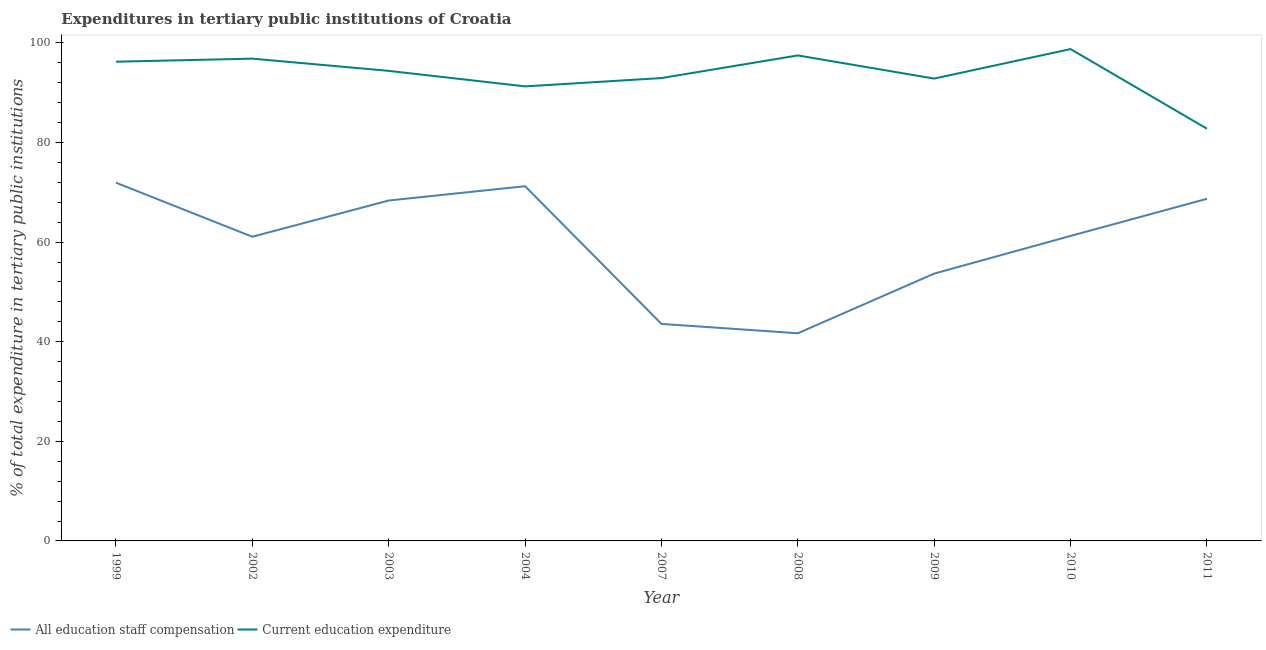How many different coloured lines are there?
Offer a terse response. 2. Is the number of lines equal to the number of legend labels?
Keep it short and to the point. Yes. What is the expenditure in education in 2004?
Provide a short and direct response. 91.28. Across all years, what is the maximum expenditure in staff compensation?
Give a very brief answer. 71.95. Across all years, what is the minimum expenditure in staff compensation?
Give a very brief answer. 41.7. In which year was the expenditure in education maximum?
Keep it short and to the point. 2010. What is the total expenditure in education in the graph?
Offer a terse response. 843.66. What is the difference between the expenditure in staff compensation in 2002 and that in 2010?
Make the answer very short. -0.17. What is the difference between the expenditure in education in 2003 and the expenditure in staff compensation in 2002?
Keep it short and to the point. 33.32. What is the average expenditure in education per year?
Keep it short and to the point. 93.74. In the year 2004, what is the difference between the expenditure in education and expenditure in staff compensation?
Give a very brief answer. 20.05. In how many years, is the expenditure in staff compensation greater than 36 %?
Provide a short and direct response. 9. What is the ratio of the expenditure in education in 2007 to that in 2008?
Your response must be concise. 0.95. Is the expenditure in education in 2008 less than that in 2011?
Ensure brevity in your answer.  No. Is the difference between the expenditure in education in 2007 and 2010 greater than the difference between the expenditure in staff compensation in 2007 and 2010?
Keep it short and to the point. Yes. What is the difference between the highest and the second highest expenditure in education?
Keep it short and to the point. 1.27. What is the difference between the highest and the lowest expenditure in staff compensation?
Give a very brief answer. 30.24. In how many years, is the expenditure in staff compensation greater than the average expenditure in staff compensation taken over all years?
Offer a very short reply. 6. Is the sum of the expenditure in education in 2007 and 2009 greater than the maximum expenditure in staff compensation across all years?
Your answer should be compact. Yes. Is the expenditure in staff compensation strictly greater than the expenditure in education over the years?
Ensure brevity in your answer.  No. Is the expenditure in education strictly less than the expenditure in staff compensation over the years?
Make the answer very short. No. What is the title of the graph?
Your response must be concise. Expenditures in tertiary public institutions of Croatia. Does "Measles" appear as one of the legend labels in the graph?
Make the answer very short. No. What is the label or title of the Y-axis?
Make the answer very short. % of total expenditure in tertiary public institutions. What is the % of total expenditure in tertiary public institutions in All education staff compensation in 1999?
Keep it short and to the point. 71.95. What is the % of total expenditure in tertiary public institutions of Current education expenditure in 1999?
Offer a very short reply. 96.24. What is the % of total expenditure in tertiary public institutions of All education staff compensation in 2002?
Make the answer very short. 61.09. What is the % of total expenditure in tertiary public institutions in Current education expenditure in 2002?
Provide a short and direct response. 96.86. What is the % of total expenditure in tertiary public institutions of All education staff compensation in 2003?
Make the answer very short. 68.37. What is the % of total expenditure in tertiary public institutions in Current education expenditure in 2003?
Offer a very short reply. 94.4. What is the % of total expenditure in tertiary public institutions of All education staff compensation in 2004?
Your answer should be very brief. 71.24. What is the % of total expenditure in tertiary public institutions in Current education expenditure in 2004?
Your response must be concise. 91.28. What is the % of total expenditure in tertiary public institutions of All education staff compensation in 2007?
Ensure brevity in your answer.  43.59. What is the % of total expenditure in tertiary public institutions of Current education expenditure in 2007?
Give a very brief answer. 92.96. What is the % of total expenditure in tertiary public institutions of All education staff compensation in 2008?
Make the answer very short. 41.7. What is the % of total expenditure in tertiary public institutions in Current education expenditure in 2008?
Provide a succinct answer. 97.5. What is the % of total expenditure in tertiary public institutions of All education staff compensation in 2009?
Offer a very short reply. 53.69. What is the % of total expenditure in tertiary public institutions of Current education expenditure in 2009?
Make the answer very short. 92.85. What is the % of total expenditure in tertiary public institutions in All education staff compensation in 2010?
Provide a short and direct response. 61.25. What is the % of total expenditure in tertiary public institutions in Current education expenditure in 2010?
Offer a terse response. 98.78. What is the % of total expenditure in tertiary public institutions in All education staff compensation in 2011?
Your answer should be compact. 68.71. What is the % of total expenditure in tertiary public institutions of Current education expenditure in 2011?
Your answer should be compact. 82.78. Across all years, what is the maximum % of total expenditure in tertiary public institutions in All education staff compensation?
Ensure brevity in your answer.  71.95. Across all years, what is the maximum % of total expenditure in tertiary public institutions in Current education expenditure?
Offer a terse response. 98.78. Across all years, what is the minimum % of total expenditure in tertiary public institutions in All education staff compensation?
Ensure brevity in your answer.  41.7. Across all years, what is the minimum % of total expenditure in tertiary public institutions in Current education expenditure?
Keep it short and to the point. 82.78. What is the total % of total expenditure in tertiary public institutions in All education staff compensation in the graph?
Your answer should be compact. 541.58. What is the total % of total expenditure in tertiary public institutions in Current education expenditure in the graph?
Provide a succinct answer. 843.66. What is the difference between the % of total expenditure in tertiary public institutions of All education staff compensation in 1999 and that in 2002?
Make the answer very short. 10.86. What is the difference between the % of total expenditure in tertiary public institutions of Current education expenditure in 1999 and that in 2002?
Your response must be concise. -0.62. What is the difference between the % of total expenditure in tertiary public institutions of All education staff compensation in 1999 and that in 2003?
Provide a succinct answer. 3.58. What is the difference between the % of total expenditure in tertiary public institutions of Current education expenditure in 1999 and that in 2003?
Keep it short and to the point. 1.84. What is the difference between the % of total expenditure in tertiary public institutions of All education staff compensation in 1999 and that in 2004?
Give a very brief answer. 0.71. What is the difference between the % of total expenditure in tertiary public institutions of Current education expenditure in 1999 and that in 2004?
Ensure brevity in your answer.  4.96. What is the difference between the % of total expenditure in tertiary public institutions in All education staff compensation in 1999 and that in 2007?
Your answer should be compact. 28.36. What is the difference between the % of total expenditure in tertiary public institutions in Current education expenditure in 1999 and that in 2007?
Your response must be concise. 3.29. What is the difference between the % of total expenditure in tertiary public institutions of All education staff compensation in 1999 and that in 2008?
Provide a succinct answer. 30.24. What is the difference between the % of total expenditure in tertiary public institutions of Current education expenditure in 1999 and that in 2008?
Offer a very short reply. -1.26. What is the difference between the % of total expenditure in tertiary public institutions in All education staff compensation in 1999 and that in 2009?
Your answer should be compact. 18.26. What is the difference between the % of total expenditure in tertiary public institutions of Current education expenditure in 1999 and that in 2009?
Keep it short and to the point. 3.39. What is the difference between the % of total expenditure in tertiary public institutions in All education staff compensation in 1999 and that in 2010?
Provide a succinct answer. 10.69. What is the difference between the % of total expenditure in tertiary public institutions of Current education expenditure in 1999 and that in 2010?
Give a very brief answer. -2.53. What is the difference between the % of total expenditure in tertiary public institutions of All education staff compensation in 1999 and that in 2011?
Offer a very short reply. 3.24. What is the difference between the % of total expenditure in tertiary public institutions of Current education expenditure in 1999 and that in 2011?
Provide a succinct answer. 13.46. What is the difference between the % of total expenditure in tertiary public institutions in All education staff compensation in 2002 and that in 2003?
Provide a short and direct response. -7.28. What is the difference between the % of total expenditure in tertiary public institutions of Current education expenditure in 2002 and that in 2003?
Your response must be concise. 2.46. What is the difference between the % of total expenditure in tertiary public institutions in All education staff compensation in 2002 and that in 2004?
Your response must be concise. -10.15. What is the difference between the % of total expenditure in tertiary public institutions of Current education expenditure in 2002 and that in 2004?
Your answer should be very brief. 5.57. What is the difference between the % of total expenditure in tertiary public institutions in All education staff compensation in 2002 and that in 2007?
Provide a succinct answer. 17.5. What is the difference between the % of total expenditure in tertiary public institutions of Current education expenditure in 2002 and that in 2007?
Keep it short and to the point. 3.9. What is the difference between the % of total expenditure in tertiary public institutions of All education staff compensation in 2002 and that in 2008?
Your answer should be very brief. 19.38. What is the difference between the % of total expenditure in tertiary public institutions of Current education expenditure in 2002 and that in 2008?
Your response must be concise. -0.64. What is the difference between the % of total expenditure in tertiary public institutions of All education staff compensation in 2002 and that in 2009?
Make the answer very short. 7.4. What is the difference between the % of total expenditure in tertiary public institutions of Current education expenditure in 2002 and that in 2009?
Offer a very short reply. 4. What is the difference between the % of total expenditure in tertiary public institutions in All education staff compensation in 2002 and that in 2010?
Your response must be concise. -0.17. What is the difference between the % of total expenditure in tertiary public institutions in Current education expenditure in 2002 and that in 2010?
Give a very brief answer. -1.92. What is the difference between the % of total expenditure in tertiary public institutions of All education staff compensation in 2002 and that in 2011?
Provide a short and direct response. -7.62. What is the difference between the % of total expenditure in tertiary public institutions in Current education expenditure in 2002 and that in 2011?
Your response must be concise. 14.07. What is the difference between the % of total expenditure in tertiary public institutions of All education staff compensation in 2003 and that in 2004?
Offer a very short reply. -2.87. What is the difference between the % of total expenditure in tertiary public institutions of Current education expenditure in 2003 and that in 2004?
Provide a short and direct response. 3.12. What is the difference between the % of total expenditure in tertiary public institutions of All education staff compensation in 2003 and that in 2007?
Your response must be concise. 24.78. What is the difference between the % of total expenditure in tertiary public institutions of Current education expenditure in 2003 and that in 2007?
Offer a terse response. 1.45. What is the difference between the % of total expenditure in tertiary public institutions in All education staff compensation in 2003 and that in 2008?
Ensure brevity in your answer.  26.66. What is the difference between the % of total expenditure in tertiary public institutions of Current education expenditure in 2003 and that in 2008?
Keep it short and to the point. -3.1. What is the difference between the % of total expenditure in tertiary public institutions of All education staff compensation in 2003 and that in 2009?
Provide a short and direct response. 14.68. What is the difference between the % of total expenditure in tertiary public institutions of Current education expenditure in 2003 and that in 2009?
Keep it short and to the point. 1.55. What is the difference between the % of total expenditure in tertiary public institutions of All education staff compensation in 2003 and that in 2010?
Offer a terse response. 7.11. What is the difference between the % of total expenditure in tertiary public institutions in Current education expenditure in 2003 and that in 2010?
Offer a very short reply. -4.37. What is the difference between the % of total expenditure in tertiary public institutions of All education staff compensation in 2003 and that in 2011?
Offer a very short reply. -0.34. What is the difference between the % of total expenditure in tertiary public institutions of Current education expenditure in 2003 and that in 2011?
Give a very brief answer. 11.62. What is the difference between the % of total expenditure in tertiary public institutions of All education staff compensation in 2004 and that in 2007?
Ensure brevity in your answer.  27.65. What is the difference between the % of total expenditure in tertiary public institutions in Current education expenditure in 2004 and that in 2007?
Give a very brief answer. -1.67. What is the difference between the % of total expenditure in tertiary public institutions of All education staff compensation in 2004 and that in 2008?
Keep it short and to the point. 29.54. What is the difference between the % of total expenditure in tertiary public institutions in Current education expenditure in 2004 and that in 2008?
Make the answer very short. -6.22. What is the difference between the % of total expenditure in tertiary public institutions in All education staff compensation in 2004 and that in 2009?
Your response must be concise. 17.55. What is the difference between the % of total expenditure in tertiary public institutions in Current education expenditure in 2004 and that in 2009?
Offer a terse response. -1.57. What is the difference between the % of total expenditure in tertiary public institutions of All education staff compensation in 2004 and that in 2010?
Provide a short and direct response. 9.98. What is the difference between the % of total expenditure in tertiary public institutions in Current education expenditure in 2004 and that in 2010?
Ensure brevity in your answer.  -7.49. What is the difference between the % of total expenditure in tertiary public institutions of All education staff compensation in 2004 and that in 2011?
Offer a very short reply. 2.53. What is the difference between the % of total expenditure in tertiary public institutions of Current education expenditure in 2004 and that in 2011?
Your answer should be very brief. 8.5. What is the difference between the % of total expenditure in tertiary public institutions in All education staff compensation in 2007 and that in 2008?
Your answer should be very brief. 1.88. What is the difference between the % of total expenditure in tertiary public institutions of Current education expenditure in 2007 and that in 2008?
Give a very brief answer. -4.55. What is the difference between the % of total expenditure in tertiary public institutions of All education staff compensation in 2007 and that in 2009?
Your response must be concise. -10.1. What is the difference between the % of total expenditure in tertiary public institutions of Current education expenditure in 2007 and that in 2009?
Provide a succinct answer. 0.1. What is the difference between the % of total expenditure in tertiary public institutions in All education staff compensation in 2007 and that in 2010?
Provide a succinct answer. -17.67. What is the difference between the % of total expenditure in tertiary public institutions of Current education expenditure in 2007 and that in 2010?
Give a very brief answer. -5.82. What is the difference between the % of total expenditure in tertiary public institutions of All education staff compensation in 2007 and that in 2011?
Offer a very short reply. -25.12. What is the difference between the % of total expenditure in tertiary public institutions of Current education expenditure in 2007 and that in 2011?
Keep it short and to the point. 10.17. What is the difference between the % of total expenditure in tertiary public institutions of All education staff compensation in 2008 and that in 2009?
Keep it short and to the point. -11.98. What is the difference between the % of total expenditure in tertiary public institutions in Current education expenditure in 2008 and that in 2009?
Your answer should be compact. 4.65. What is the difference between the % of total expenditure in tertiary public institutions of All education staff compensation in 2008 and that in 2010?
Provide a short and direct response. -19.55. What is the difference between the % of total expenditure in tertiary public institutions in Current education expenditure in 2008 and that in 2010?
Ensure brevity in your answer.  -1.27. What is the difference between the % of total expenditure in tertiary public institutions in All education staff compensation in 2008 and that in 2011?
Your answer should be very brief. -27.01. What is the difference between the % of total expenditure in tertiary public institutions in Current education expenditure in 2008 and that in 2011?
Offer a very short reply. 14.72. What is the difference between the % of total expenditure in tertiary public institutions in All education staff compensation in 2009 and that in 2010?
Make the answer very short. -7.57. What is the difference between the % of total expenditure in tertiary public institutions in Current education expenditure in 2009 and that in 2010?
Your response must be concise. -5.92. What is the difference between the % of total expenditure in tertiary public institutions in All education staff compensation in 2009 and that in 2011?
Provide a succinct answer. -15.02. What is the difference between the % of total expenditure in tertiary public institutions in Current education expenditure in 2009 and that in 2011?
Provide a short and direct response. 10.07. What is the difference between the % of total expenditure in tertiary public institutions of All education staff compensation in 2010 and that in 2011?
Keep it short and to the point. -7.46. What is the difference between the % of total expenditure in tertiary public institutions in Current education expenditure in 2010 and that in 2011?
Provide a succinct answer. 15.99. What is the difference between the % of total expenditure in tertiary public institutions of All education staff compensation in 1999 and the % of total expenditure in tertiary public institutions of Current education expenditure in 2002?
Give a very brief answer. -24.91. What is the difference between the % of total expenditure in tertiary public institutions of All education staff compensation in 1999 and the % of total expenditure in tertiary public institutions of Current education expenditure in 2003?
Keep it short and to the point. -22.46. What is the difference between the % of total expenditure in tertiary public institutions in All education staff compensation in 1999 and the % of total expenditure in tertiary public institutions in Current education expenditure in 2004?
Ensure brevity in your answer.  -19.34. What is the difference between the % of total expenditure in tertiary public institutions in All education staff compensation in 1999 and the % of total expenditure in tertiary public institutions in Current education expenditure in 2007?
Keep it short and to the point. -21.01. What is the difference between the % of total expenditure in tertiary public institutions of All education staff compensation in 1999 and the % of total expenditure in tertiary public institutions of Current education expenditure in 2008?
Your response must be concise. -25.55. What is the difference between the % of total expenditure in tertiary public institutions of All education staff compensation in 1999 and the % of total expenditure in tertiary public institutions of Current education expenditure in 2009?
Ensure brevity in your answer.  -20.91. What is the difference between the % of total expenditure in tertiary public institutions in All education staff compensation in 1999 and the % of total expenditure in tertiary public institutions in Current education expenditure in 2010?
Provide a succinct answer. -26.83. What is the difference between the % of total expenditure in tertiary public institutions in All education staff compensation in 1999 and the % of total expenditure in tertiary public institutions in Current education expenditure in 2011?
Keep it short and to the point. -10.84. What is the difference between the % of total expenditure in tertiary public institutions in All education staff compensation in 2002 and the % of total expenditure in tertiary public institutions in Current education expenditure in 2003?
Offer a terse response. -33.32. What is the difference between the % of total expenditure in tertiary public institutions in All education staff compensation in 2002 and the % of total expenditure in tertiary public institutions in Current education expenditure in 2004?
Your answer should be compact. -30.2. What is the difference between the % of total expenditure in tertiary public institutions in All education staff compensation in 2002 and the % of total expenditure in tertiary public institutions in Current education expenditure in 2007?
Give a very brief answer. -31.87. What is the difference between the % of total expenditure in tertiary public institutions in All education staff compensation in 2002 and the % of total expenditure in tertiary public institutions in Current education expenditure in 2008?
Provide a short and direct response. -36.42. What is the difference between the % of total expenditure in tertiary public institutions in All education staff compensation in 2002 and the % of total expenditure in tertiary public institutions in Current education expenditure in 2009?
Provide a succinct answer. -31.77. What is the difference between the % of total expenditure in tertiary public institutions of All education staff compensation in 2002 and the % of total expenditure in tertiary public institutions of Current education expenditure in 2010?
Your answer should be compact. -37.69. What is the difference between the % of total expenditure in tertiary public institutions in All education staff compensation in 2002 and the % of total expenditure in tertiary public institutions in Current education expenditure in 2011?
Your answer should be very brief. -21.7. What is the difference between the % of total expenditure in tertiary public institutions in All education staff compensation in 2003 and the % of total expenditure in tertiary public institutions in Current education expenditure in 2004?
Offer a very short reply. -22.92. What is the difference between the % of total expenditure in tertiary public institutions in All education staff compensation in 2003 and the % of total expenditure in tertiary public institutions in Current education expenditure in 2007?
Provide a succinct answer. -24.59. What is the difference between the % of total expenditure in tertiary public institutions of All education staff compensation in 2003 and the % of total expenditure in tertiary public institutions of Current education expenditure in 2008?
Provide a short and direct response. -29.14. What is the difference between the % of total expenditure in tertiary public institutions in All education staff compensation in 2003 and the % of total expenditure in tertiary public institutions in Current education expenditure in 2009?
Give a very brief answer. -24.49. What is the difference between the % of total expenditure in tertiary public institutions of All education staff compensation in 2003 and the % of total expenditure in tertiary public institutions of Current education expenditure in 2010?
Your response must be concise. -30.41. What is the difference between the % of total expenditure in tertiary public institutions in All education staff compensation in 2003 and the % of total expenditure in tertiary public institutions in Current education expenditure in 2011?
Offer a terse response. -14.42. What is the difference between the % of total expenditure in tertiary public institutions of All education staff compensation in 2004 and the % of total expenditure in tertiary public institutions of Current education expenditure in 2007?
Keep it short and to the point. -21.72. What is the difference between the % of total expenditure in tertiary public institutions of All education staff compensation in 2004 and the % of total expenditure in tertiary public institutions of Current education expenditure in 2008?
Offer a very short reply. -26.26. What is the difference between the % of total expenditure in tertiary public institutions in All education staff compensation in 2004 and the % of total expenditure in tertiary public institutions in Current education expenditure in 2009?
Your answer should be very brief. -21.62. What is the difference between the % of total expenditure in tertiary public institutions in All education staff compensation in 2004 and the % of total expenditure in tertiary public institutions in Current education expenditure in 2010?
Your answer should be compact. -27.54. What is the difference between the % of total expenditure in tertiary public institutions in All education staff compensation in 2004 and the % of total expenditure in tertiary public institutions in Current education expenditure in 2011?
Make the answer very short. -11.54. What is the difference between the % of total expenditure in tertiary public institutions in All education staff compensation in 2007 and the % of total expenditure in tertiary public institutions in Current education expenditure in 2008?
Provide a succinct answer. -53.92. What is the difference between the % of total expenditure in tertiary public institutions of All education staff compensation in 2007 and the % of total expenditure in tertiary public institutions of Current education expenditure in 2009?
Keep it short and to the point. -49.27. What is the difference between the % of total expenditure in tertiary public institutions of All education staff compensation in 2007 and the % of total expenditure in tertiary public institutions of Current education expenditure in 2010?
Your answer should be compact. -55.19. What is the difference between the % of total expenditure in tertiary public institutions of All education staff compensation in 2007 and the % of total expenditure in tertiary public institutions of Current education expenditure in 2011?
Ensure brevity in your answer.  -39.2. What is the difference between the % of total expenditure in tertiary public institutions in All education staff compensation in 2008 and the % of total expenditure in tertiary public institutions in Current education expenditure in 2009?
Provide a short and direct response. -51.15. What is the difference between the % of total expenditure in tertiary public institutions in All education staff compensation in 2008 and the % of total expenditure in tertiary public institutions in Current education expenditure in 2010?
Offer a terse response. -57.07. What is the difference between the % of total expenditure in tertiary public institutions in All education staff compensation in 2008 and the % of total expenditure in tertiary public institutions in Current education expenditure in 2011?
Your answer should be very brief. -41.08. What is the difference between the % of total expenditure in tertiary public institutions of All education staff compensation in 2009 and the % of total expenditure in tertiary public institutions of Current education expenditure in 2010?
Your answer should be compact. -45.09. What is the difference between the % of total expenditure in tertiary public institutions of All education staff compensation in 2009 and the % of total expenditure in tertiary public institutions of Current education expenditure in 2011?
Make the answer very short. -29.1. What is the difference between the % of total expenditure in tertiary public institutions of All education staff compensation in 2010 and the % of total expenditure in tertiary public institutions of Current education expenditure in 2011?
Give a very brief answer. -21.53. What is the average % of total expenditure in tertiary public institutions in All education staff compensation per year?
Your response must be concise. 60.18. What is the average % of total expenditure in tertiary public institutions of Current education expenditure per year?
Offer a very short reply. 93.74. In the year 1999, what is the difference between the % of total expenditure in tertiary public institutions in All education staff compensation and % of total expenditure in tertiary public institutions in Current education expenditure?
Offer a very short reply. -24.29. In the year 2002, what is the difference between the % of total expenditure in tertiary public institutions in All education staff compensation and % of total expenditure in tertiary public institutions in Current education expenditure?
Your answer should be compact. -35.77. In the year 2003, what is the difference between the % of total expenditure in tertiary public institutions of All education staff compensation and % of total expenditure in tertiary public institutions of Current education expenditure?
Your answer should be very brief. -26.04. In the year 2004, what is the difference between the % of total expenditure in tertiary public institutions in All education staff compensation and % of total expenditure in tertiary public institutions in Current education expenditure?
Provide a short and direct response. -20.05. In the year 2007, what is the difference between the % of total expenditure in tertiary public institutions of All education staff compensation and % of total expenditure in tertiary public institutions of Current education expenditure?
Give a very brief answer. -49.37. In the year 2008, what is the difference between the % of total expenditure in tertiary public institutions of All education staff compensation and % of total expenditure in tertiary public institutions of Current education expenditure?
Give a very brief answer. -55.8. In the year 2009, what is the difference between the % of total expenditure in tertiary public institutions of All education staff compensation and % of total expenditure in tertiary public institutions of Current education expenditure?
Your answer should be very brief. -39.17. In the year 2010, what is the difference between the % of total expenditure in tertiary public institutions of All education staff compensation and % of total expenditure in tertiary public institutions of Current education expenditure?
Give a very brief answer. -37.52. In the year 2011, what is the difference between the % of total expenditure in tertiary public institutions of All education staff compensation and % of total expenditure in tertiary public institutions of Current education expenditure?
Provide a short and direct response. -14.07. What is the ratio of the % of total expenditure in tertiary public institutions in All education staff compensation in 1999 to that in 2002?
Your answer should be very brief. 1.18. What is the ratio of the % of total expenditure in tertiary public institutions of All education staff compensation in 1999 to that in 2003?
Provide a succinct answer. 1.05. What is the ratio of the % of total expenditure in tertiary public institutions in Current education expenditure in 1999 to that in 2003?
Keep it short and to the point. 1.02. What is the ratio of the % of total expenditure in tertiary public institutions of Current education expenditure in 1999 to that in 2004?
Your answer should be compact. 1.05. What is the ratio of the % of total expenditure in tertiary public institutions of All education staff compensation in 1999 to that in 2007?
Ensure brevity in your answer.  1.65. What is the ratio of the % of total expenditure in tertiary public institutions of Current education expenditure in 1999 to that in 2007?
Provide a succinct answer. 1.04. What is the ratio of the % of total expenditure in tertiary public institutions of All education staff compensation in 1999 to that in 2008?
Offer a very short reply. 1.73. What is the ratio of the % of total expenditure in tertiary public institutions of Current education expenditure in 1999 to that in 2008?
Offer a very short reply. 0.99. What is the ratio of the % of total expenditure in tertiary public institutions of All education staff compensation in 1999 to that in 2009?
Give a very brief answer. 1.34. What is the ratio of the % of total expenditure in tertiary public institutions of Current education expenditure in 1999 to that in 2009?
Your answer should be very brief. 1.04. What is the ratio of the % of total expenditure in tertiary public institutions of All education staff compensation in 1999 to that in 2010?
Make the answer very short. 1.17. What is the ratio of the % of total expenditure in tertiary public institutions of Current education expenditure in 1999 to that in 2010?
Make the answer very short. 0.97. What is the ratio of the % of total expenditure in tertiary public institutions in All education staff compensation in 1999 to that in 2011?
Offer a terse response. 1.05. What is the ratio of the % of total expenditure in tertiary public institutions of Current education expenditure in 1999 to that in 2011?
Give a very brief answer. 1.16. What is the ratio of the % of total expenditure in tertiary public institutions of All education staff compensation in 2002 to that in 2003?
Provide a succinct answer. 0.89. What is the ratio of the % of total expenditure in tertiary public institutions of Current education expenditure in 2002 to that in 2003?
Ensure brevity in your answer.  1.03. What is the ratio of the % of total expenditure in tertiary public institutions of All education staff compensation in 2002 to that in 2004?
Your answer should be compact. 0.86. What is the ratio of the % of total expenditure in tertiary public institutions in Current education expenditure in 2002 to that in 2004?
Provide a succinct answer. 1.06. What is the ratio of the % of total expenditure in tertiary public institutions of All education staff compensation in 2002 to that in 2007?
Offer a very short reply. 1.4. What is the ratio of the % of total expenditure in tertiary public institutions in Current education expenditure in 2002 to that in 2007?
Keep it short and to the point. 1.04. What is the ratio of the % of total expenditure in tertiary public institutions in All education staff compensation in 2002 to that in 2008?
Ensure brevity in your answer.  1.46. What is the ratio of the % of total expenditure in tertiary public institutions in All education staff compensation in 2002 to that in 2009?
Provide a succinct answer. 1.14. What is the ratio of the % of total expenditure in tertiary public institutions of Current education expenditure in 2002 to that in 2009?
Keep it short and to the point. 1.04. What is the ratio of the % of total expenditure in tertiary public institutions in Current education expenditure in 2002 to that in 2010?
Provide a succinct answer. 0.98. What is the ratio of the % of total expenditure in tertiary public institutions in All education staff compensation in 2002 to that in 2011?
Your answer should be compact. 0.89. What is the ratio of the % of total expenditure in tertiary public institutions of Current education expenditure in 2002 to that in 2011?
Your response must be concise. 1.17. What is the ratio of the % of total expenditure in tertiary public institutions in All education staff compensation in 2003 to that in 2004?
Offer a very short reply. 0.96. What is the ratio of the % of total expenditure in tertiary public institutions in Current education expenditure in 2003 to that in 2004?
Provide a succinct answer. 1.03. What is the ratio of the % of total expenditure in tertiary public institutions in All education staff compensation in 2003 to that in 2007?
Provide a succinct answer. 1.57. What is the ratio of the % of total expenditure in tertiary public institutions in Current education expenditure in 2003 to that in 2007?
Keep it short and to the point. 1.02. What is the ratio of the % of total expenditure in tertiary public institutions in All education staff compensation in 2003 to that in 2008?
Keep it short and to the point. 1.64. What is the ratio of the % of total expenditure in tertiary public institutions in Current education expenditure in 2003 to that in 2008?
Give a very brief answer. 0.97. What is the ratio of the % of total expenditure in tertiary public institutions of All education staff compensation in 2003 to that in 2009?
Make the answer very short. 1.27. What is the ratio of the % of total expenditure in tertiary public institutions of Current education expenditure in 2003 to that in 2009?
Your answer should be compact. 1.02. What is the ratio of the % of total expenditure in tertiary public institutions in All education staff compensation in 2003 to that in 2010?
Keep it short and to the point. 1.12. What is the ratio of the % of total expenditure in tertiary public institutions of Current education expenditure in 2003 to that in 2010?
Ensure brevity in your answer.  0.96. What is the ratio of the % of total expenditure in tertiary public institutions in All education staff compensation in 2003 to that in 2011?
Give a very brief answer. 0.99. What is the ratio of the % of total expenditure in tertiary public institutions in Current education expenditure in 2003 to that in 2011?
Make the answer very short. 1.14. What is the ratio of the % of total expenditure in tertiary public institutions of All education staff compensation in 2004 to that in 2007?
Your answer should be compact. 1.63. What is the ratio of the % of total expenditure in tertiary public institutions in Current education expenditure in 2004 to that in 2007?
Offer a terse response. 0.98. What is the ratio of the % of total expenditure in tertiary public institutions in All education staff compensation in 2004 to that in 2008?
Provide a succinct answer. 1.71. What is the ratio of the % of total expenditure in tertiary public institutions of Current education expenditure in 2004 to that in 2008?
Give a very brief answer. 0.94. What is the ratio of the % of total expenditure in tertiary public institutions in All education staff compensation in 2004 to that in 2009?
Give a very brief answer. 1.33. What is the ratio of the % of total expenditure in tertiary public institutions of Current education expenditure in 2004 to that in 2009?
Offer a terse response. 0.98. What is the ratio of the % of total expenditure in tertiary public institutions in All education staff compensation in 2004 to that in 2010?
Ensure brevity in your answer.  1.16. What is the ratio of the % of total expenditure in tertiary public institutions in Current education expenditure in 2004 to that in 2010?
Offer a very short reply. 0.92. What is the ratio of the % of total expenditure in tertiary public institutions in All education staff compensation in 2004 to that in 2011?
Provide a succinct answer. 1.04. What is the ratio of the % of total expenditure in tertiary public institutions in Current education expenditure in 2004 to that in 2011?
Offer a very short reply. 1.1. What is the ratio of the % of total expenditure in tertiary public institutions in All education staff compensation in 2007 to that in 2008?
Ensure brevity in your answer.  1.05. What is the ratio of the % of total expenditure in tertiary public institutions of Current education expenditure in 2007 to that in 2008?
Your answer should be very brief. 0.95. What is the ratio of the % of total expenditure in tertiary public institutions in All education staff compensation in 2007 to that in 2009?
Provide a succinct answer. 0.81. What is the ratio of the % of total expenditure in tertiary public institutions of All education staff compensation in 2007 to that in 2010?
Your answer should be very brief. 0.71. What is the ratio of the % of total expenditure in tertiary public institutions of Current education expenditure in 2007 to that in 2010?
Your answer should be very brief. 0.94. What is the ratio of the % of total expenditure in tertiary public institutions in All education staff compensation in 2007 to that in 2011?
Your response must be concise. 0.63. What is the ratio of the % of total expenditure in tertiary public institutions of Current education expenditure in 2007 to that in 2011?
Your response must be concise. 1.12. What is the ratio of the % of total expenditure in tertiary public institutions of All education staff compensation in 2008 to that in 2009?
Your answer should be compact. 0.78. What is the ratio of the % of total expenditure in tertiary public institutions of Current education expenditure in 2008 to that in 2009?
Keep it short and to the point. 1.05. What is the ratio of the % of total expenditure in tertiary public institutions of All education staff compensation in 2008 to that in 2010?
Your response must be concise. 0.68. What is the ratio of the % of total expenditure in tertiary public institutions in Current education expenditure in 2008 to that in 2010?
Offer a terse response. 0.99. What is the ratio of the % of total expenditure in tertiary public institutions in All education staff compensation in 2008 to that in 2011?
Your answer should be compact. 0.61. What is the ratio of the % of total expenditure in tertiary public institutions in Current education expenditure in 2008 to that in 2011?
Keep it short and to the point. 1.18. What is the ratio of the % of total expenditure in tertiary public institutions of All education staff compensation in 2009 to that in 2010?
Ensure brevity in your answer.  0.88. What is the ratio of the % of total expenditure in tertiary public institutions in All education staff compensation in 2009 to that in 2011?
Provide a succinct answer. 0.78. What is the ratio of the % of total expenditure in tertiary public institutions in Current education expenditure in 2009 to that in 2011?
Give a very brief answer. 1.12. What is the ratio of the % of total expenditure in tertiary public institutions in All education staff compensation in 2010 to that in 2011?
Your answer should be compact. 0.89. What is the ratio of the % of total expenditure in tertiary public institutions of Current education expenditure in 2010 to that in 2011?
Ensure brevity in your answer.  1.19. What is the difference between the highest and the second highest % of total expenditure in tertiary public institutions in All education staff compensation?
Provide a short and direct response. 0.71. What is the difference between the highest and the second highest % of total expenditure in tertiary public institutions of Current education expenditure?
Give a very brief answer. 1.27. What is the difference between the highest and the lowest % of total expenditure in tertiary public institutions of All education staff compensation?
Provide a short and direct response. 30.24. What is the difference between the highest and the lowest % of total expenditure in tertiary public institutions in Current education expenditure?
Your answer should be compact. 15.99. 